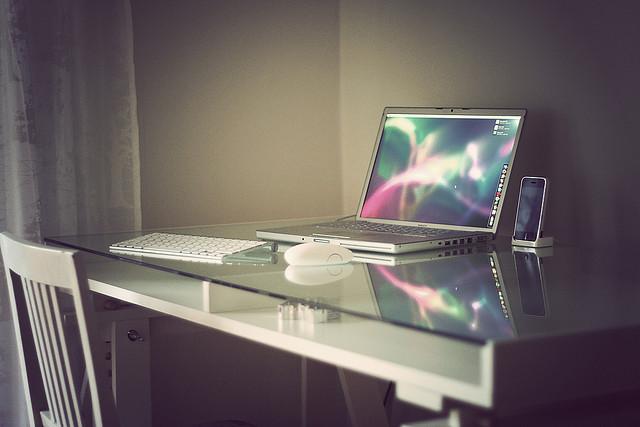What is standing right next to the laptop?
Quick response, please. Phone. What color is the wall?
Quick response, please. Gray. Is the computer shutting down?
Write a very short answer. No. Is the desk bolted together?
Quick response, please. Yes. 